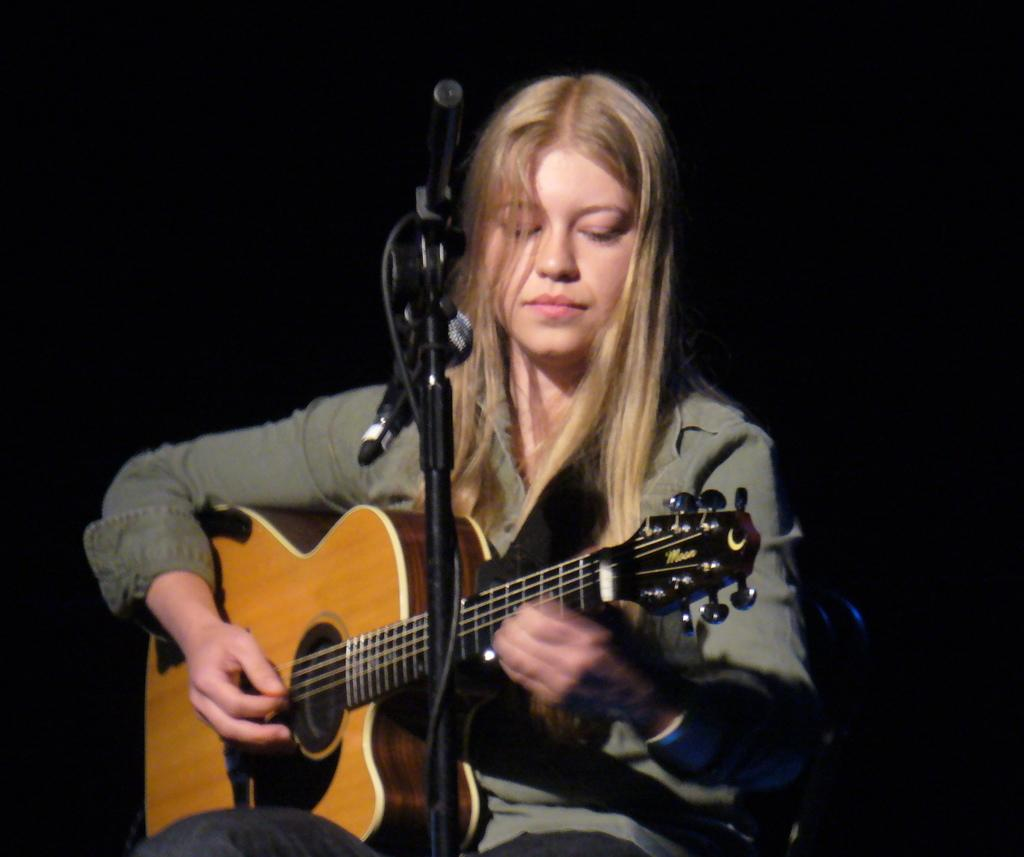Who is the main subject in the image? There is a woman in the image. What is the woman doing in the image? The woman is playing a guitar. What object is in front of the woman? There is a microphone in front of the woman. How would you describe the background of the image? The background of the image is dark. What grade is the woman teaching in the image? There is no indication in the image that the woman is teaching, nor is there any reference to a grade. 